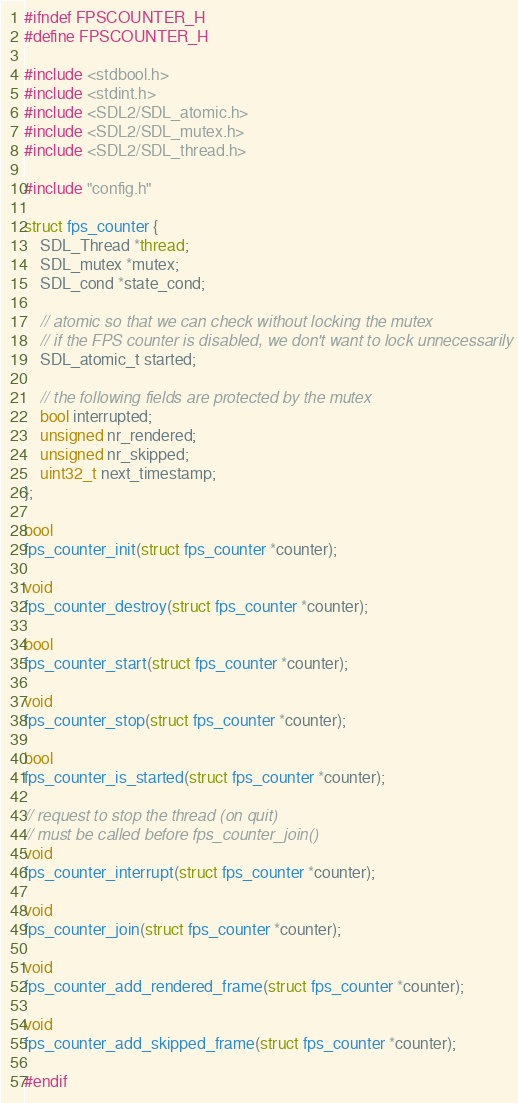Convert code to text. <code><loc_0><loc_0><loc_500><loc_500><_C_>#ifndef FPSCOUNTER_H
#define FPSCOUNTER_H

#include <stdbool.h>
#include <stdint.h>
#include <SDL2/SDL_atomic.h>
#include <SDL2/SDL_mutex.h>
#include <SDL2/SDL_thread.h>

#include "config.h"

struct fps_counter {
    SDL_Thread *thread;
    SDL_mutex *mutex;
    SDL_cond *state_cond;

    // atomic so that we can check without locking the mutex
    // if the FPS counter is disabled, we don't want to lock unnecessarily
    SDL_atomic_t started;

    // the following fields are protected by the mutex
    bool interrupted;
    unsigned nr_rendered;
    unsigned nr_skipped;
    uint32_t next_timestamp;
};

bool
fps_counter_init(struct fps_counter *counter);

void
fps_counter_destroy(struct fps_counter *counter);

bool
fps_counter_start(struct fps_counter *counter);

void
fps_counter_stop(struct fps_counter *counter);

bool
fps_counter_is_started(struct fps_counter *counter);

// request to stop the thread (on quit)
// must be called before fps_counter_join()
void
fps_counter_interrupt(struct fps_counter *counter);

void
fps_counter_join(struct fps_counter *counter);

void
fps_counter_add_rendered_frame(struct fps_counter *counter);

void
fps_counter_add_skipped_frame(struct fps_counter *counter);

#endif
</code> 